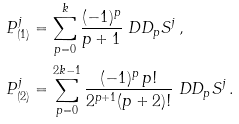<formula> <loc_0><loc_0><loc_500><loc_500>P _ { ( 1 ) } ^ { j } & = \sum _ { p = 0 } ^ { k } \frac { ( - 1 ) ^ { p } } { p + 1 } \ D D _ { p } S ^ { j } \, , \\ P _ { ( 2 ) } ^ { j } & = \sum _ { p = 0 } ^ { 2 k - 1 } \frac { ( - 1 ) ^ { p } \, p ! } { 2 ^ { p + 1 } ( p + 2 ) ! } \ D D _ { p } S ^ { j } \, .</formula> 